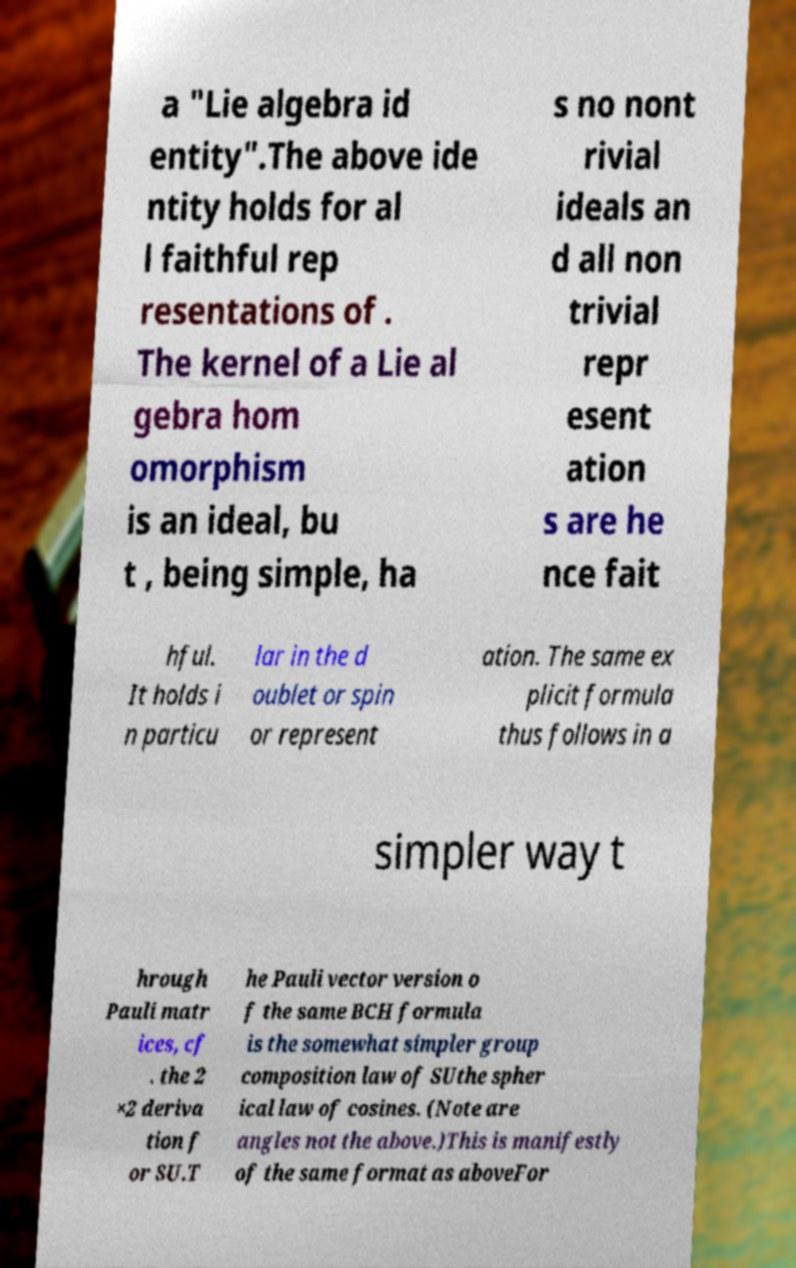Could you assist in decoding the text presented in this image and type it out clearly? a "Lie algebra id entity".The above ide ntity holds for al l faithful rep resentations of . The kernel of a Lie al gebra hom omorphism is an ideal, bu t , being simple, ha s no nont rivial ideals an d all non trivial repr esent ation s are he nce fait hful. It holds i n particu lar in the d oublet or spin or represent ation. The same ex plicit formula thus follows in a simpler way t hrough Pauli matr ices, cf . the 2 ×2 deriva tion f or SU.T he Pauli vector version o f the same BCH formula is the somewhat simpler group composition law of SUthe spher ical law of cosines. (Note are angles not the above.)This is manifestly of the same format as aboveFor 